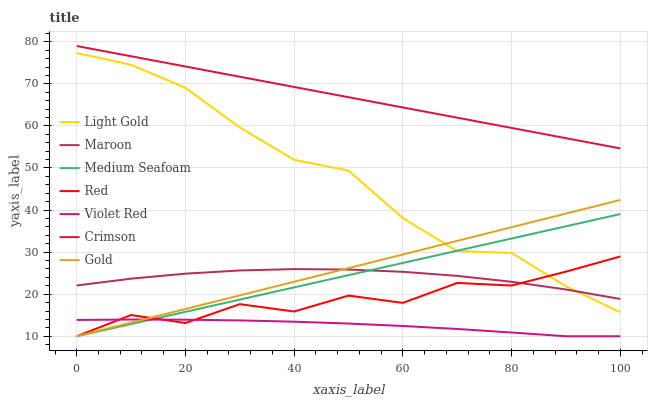Does Violet Red have the minimum area under the curve?
Answer yes or no. Yes. Does Crimson have the maximum area under the curve?
Answer yes or no. Yes. Does Gold have the minimum area under the curve?
Answer yes or no. No. Does Gold have the maximum area under the curve?
Answer yes or no. No. Is Gold the smoothest?
Answer yes or no. Yes. Is Red the roughest?
Answer yes or no. Yes. Is Maroon the smoothest?
Answer yes or no. No. Is Maroon the roughest?
Answer yes or no. No. Does Violet Red have the lowest value?
Answer yes or no. Yes. Does Maroon have the lowest value?
Answer yes or no. No. Does Crimson have the highest value?
Answer yes or no. Yes. Does Gold have the highest value?
Answer yes or no. No. Is Red less than Crimson?
Answer yes or no. Yes. Is Crimson greater than Red?
Answer yes or no. Yes. Does Red intersect Gold?
Answer yes or no. Yes. Is Red less than Gold?
Answer yes or no. No. Is Red greater than Gold?
Answer yes or no. No. Does Red intersect Crimson?
Answer yes or no. No. 